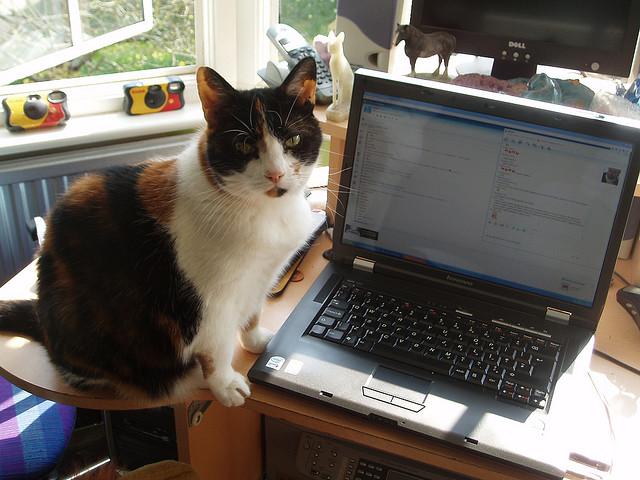How many monitors are in this picture?
Keep it brief. 2. How many cats are in this picture?
Give a very brief answer. 1. Are there cameras in this image?
Be succinct. Yes. Is the kitty cat going to put his paw on the keyboard?
Concise answer only. No. 